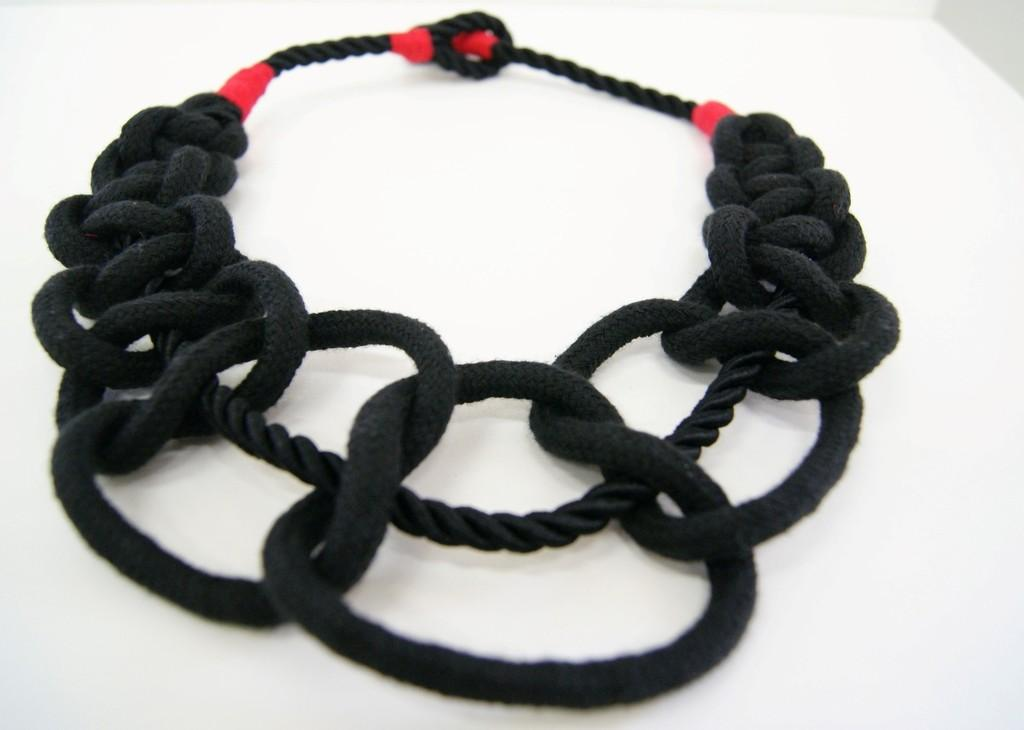What color is the rope in the picture? The rope in the picture is black. Are there any additional colors or decorations on the rope? Yes, the rope has red color decoration. What is the background or surface on which the rope is placed? The rope is placed on a white surface. What type of needle is used to create the print on the mask in the image? There is no mask or print present in the image; it features a black rope with red color decoration placed on a white surface. 